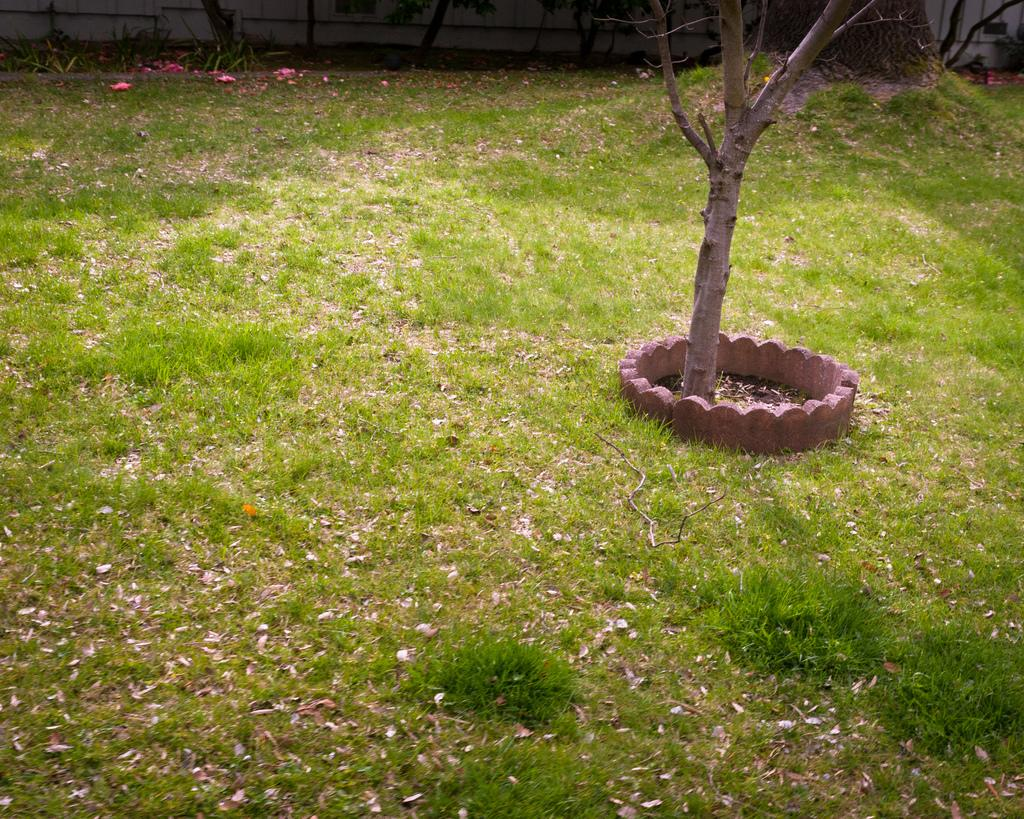What type of landscape is in the foreground of the image? There is a grassland in the foreground of the image. What can be seen in the middle of the image? There is a tree in the middle of the image. What surrounds the tree in the image? There is a stone boundary around the tree. What is visible at the top of the image? There are trees and a wall visible at the top of the image. What reason does the writer give for the parent's decision in the image? There is no writer or parent present in the image, and therefore no such decision or reason can be observed. 